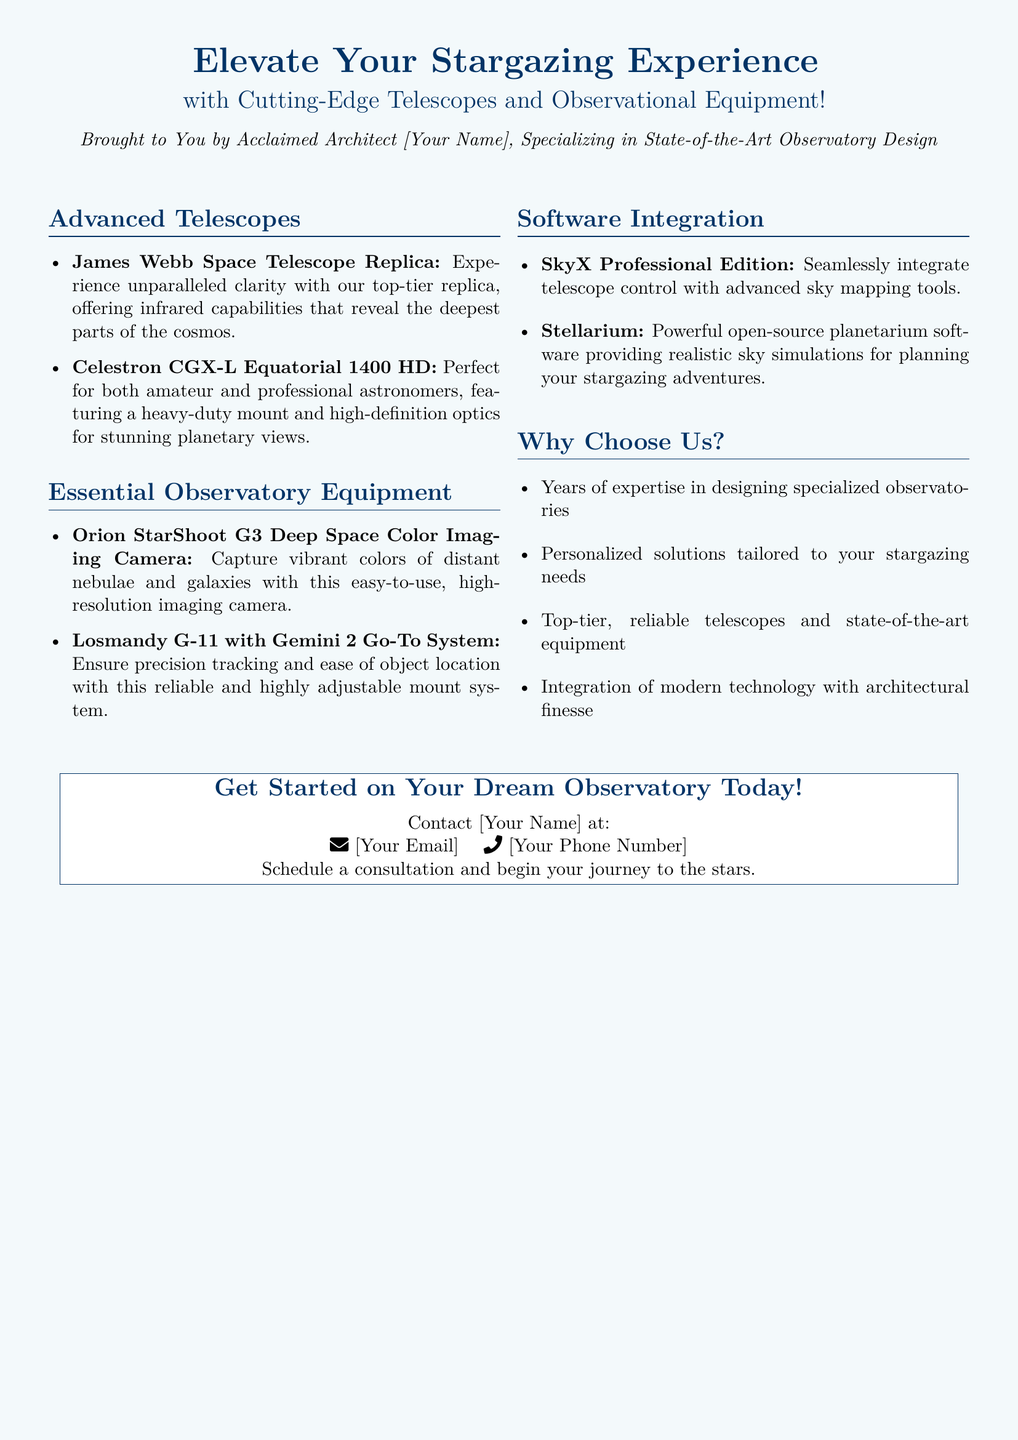What telescope is a replica featured in the advertisement? The document mentions the James Webb Space Telescope Replica as a featured telescope, which offers unparalleled clarity.
Answer: James Webb Space Telescope Replica What is the optical feature of the Celestron CGX-L Equatorial 1400 HD? The advertisement highlights its high-definition optics for stunning planetary views.
Answer: High-definition optics Which camera is mentioned for deep space imaging? The Orion StarShoot G3 Deep Space Color Imaging Camera is specified as a device for capturing vibrant colors of distant objects.
Answer: Orion StarShoot G3 What is the primary function of the Losmandy G-11? It is designed to ensure precision tracking and ease of object location for astronomers.
Answer: Precision tracking What software is suggested for telescope control? The SkyX Professional Edition is recommended for seamless integration with telescope control.
Answer: SkyX Professional Edition How many telescopes are listed in the advertisement? There are two telescopes mentioned in the document under the Advanced Telescopes section.
Answer: Two What unique architectural aspect does the advertisement emphasize? It emphasizes the integration of modern technology with architectural finesse in observatory design.
Answer: Architectural finesse How does the advertisement address potential customers? It encourages potential customers to contact the architect for consultation about their dream observatory.
Answer: Contact for consultation 